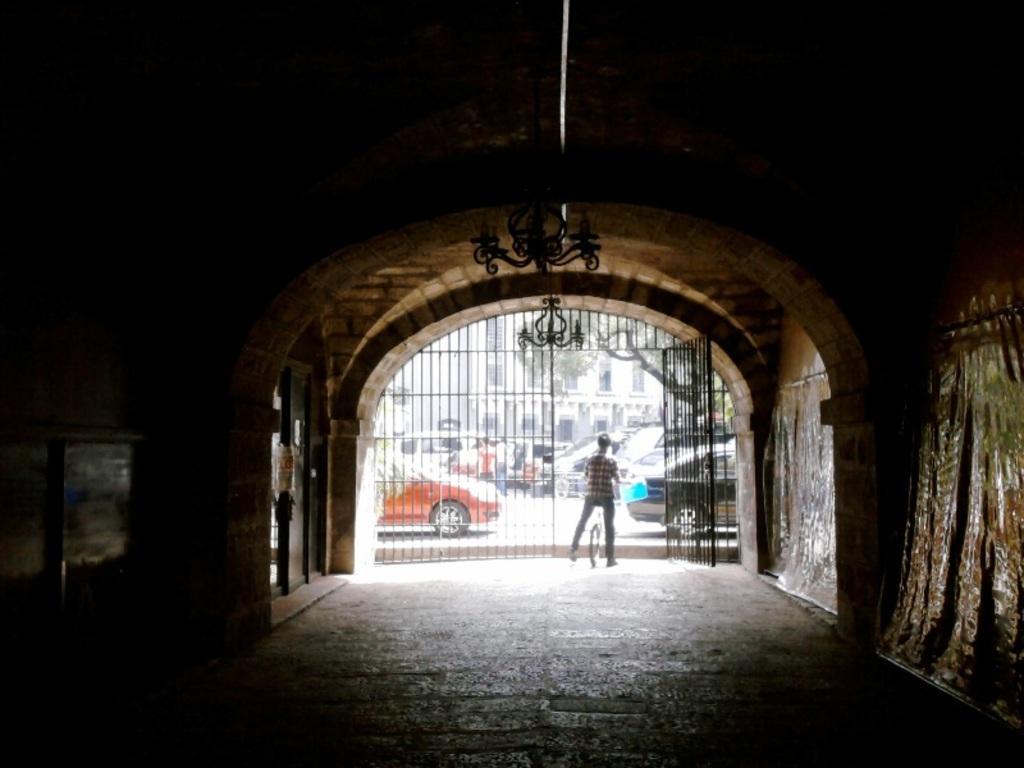Describe this image in one or two sentences. In this image there is a building, there are windows, there are doors, there is road, there are cars on the road, there are persons walking on the road, there is a bicycle, there is a man sitting on the bicycle, he is holding an object, there is a gate, there is a wall towards the right of the image, there is a wall towards the left of the image, there is a roof towards the left of the image, there is an object towards the top of the image, there is ground towards the bottom of the image. 